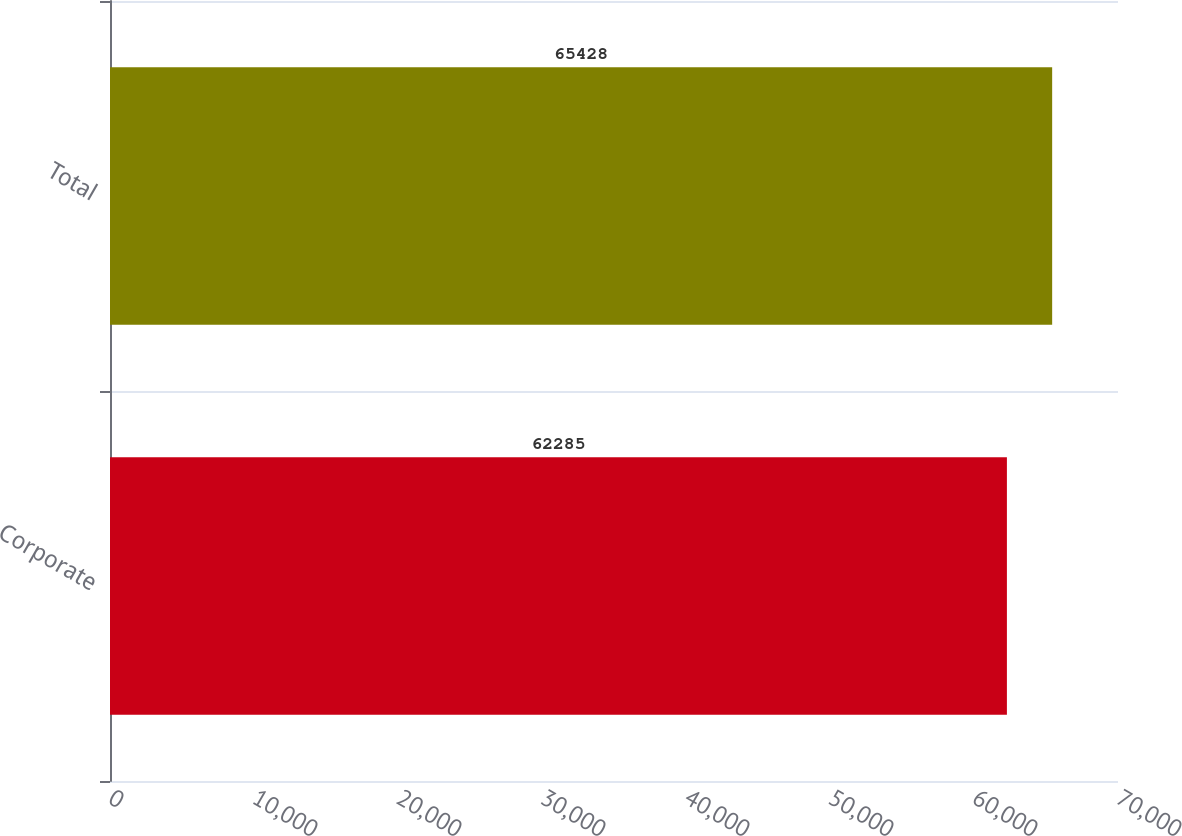Convert chart. <chart><loc_0><loc_0><loc_500><loc_500><bar_chart><fcel>Corporate<fcel>Total<nl><fcel>62285<fcel>65428<nl></chart> 